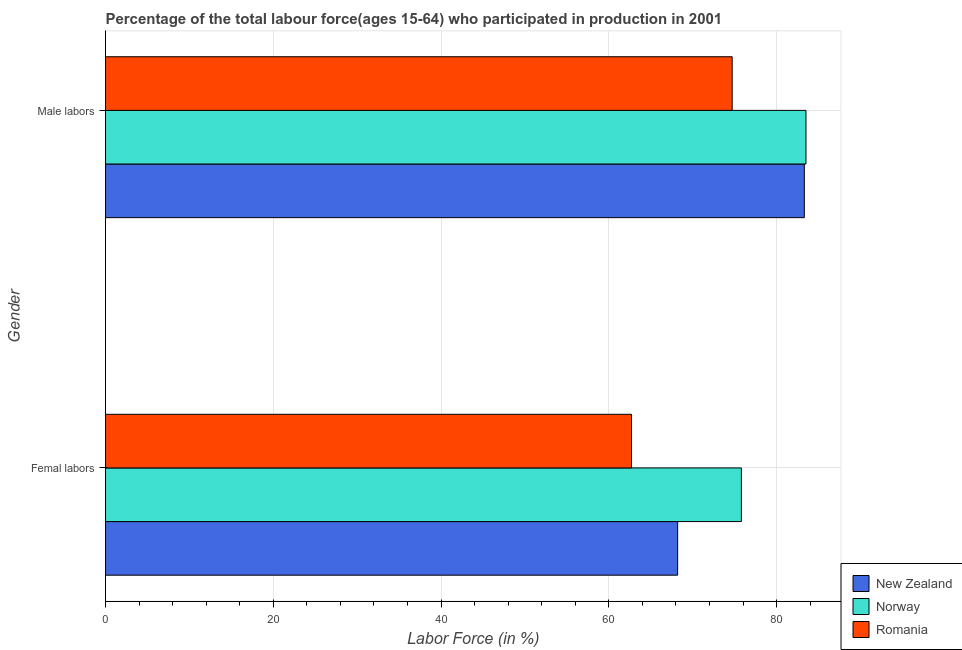How many groups of bars are there?
Keep it short and to the point. 2. Are the number of bars per tick equal to the number of legend labels?
Keep it short and to the point. Yes. How many bars are there on the 2nd tick from the top?
Offer a very short reply. 3. How many bars are there on the 1st tick from the bottom?
Offer a terse response. 3. What is the label of the 2nd group of bars from the top?
Provide a succinct answer. Femal labors. What is the percentage of female labor force in Norway?
Keep it short and to the point. 75.8. Across all countries, what is the maximum percentage of male labour force?
Offer a terse response. 83.5. Across all countries, what is the minimum percentage of male labour force?
Keep it short and to the point. 74.7. In which country was the percentage of male labour force maximum?
Give a very brief answer. Norway. In which country was the percentage of male labour force minimum?
Provide a succinct answer. Romania. What is the total percentage of female labor force in the graph?
Keep it short and to the point. 206.7. What is the difference between the percentage of female labor force in Romania and that in New Zealand?
Provide a short and direct response. -5.5. What is the difference between the percentage of female labor force in New Zealand and the percentage of male labour force in Romania?
Ensure brevity in your answer.  -6.5. What is the average percentage of female labor force per country?
Your answer should be compact. 68.9. What is the difference between the percentage of male labour force and percentage of female labor force in Romania?
Your answer should be compact. 12. In how many countries, is the percentage of female labor force greater than 52 %?
Give a very brief answer. 3. What is the ratio of the percentage of male labour force in Romania to that in Norway?
Provide a short and direct response. 0.89. Is the percentage of female labor force in Romania less than that in Norway?
Your answer should be compact. Yes. What does the 1st bar from the top in Femal labors represents?
Keep it short and to the point. Romania. How many bars are there?
Make the answer very short. 6. What is the difference between two consecutive major ticks on the X-axis?
Keep it short and to the point. 20. Are the values on the major ticks of X-axis written in scientific E-notation?
Keep it short and to the point. No. Does the graph contain grids?
Your response must be concise. Yes. What is the title of the graph?
Your answer should be compact. Percentage of the total labour force(ages 15-64) who participated in production in 2001. What is the label or title of the X-axis?
Make the answer very short. Labor Force (in %). What is the label or title of the Y-axis?
Give a very brief answer. Gender. What is the Labor Force (in %) in New Zealand in Femal labors?
Your answer should be compact. 68.2. What is the Labor Force (in %) of Norway in Femal labors?
Keep it short and to the point. 75.8. What is the Labor Force (in %) of Romania in Femal labors?
Keep it short and to the point. 62.7. What is the Labor Force (in %) in New Zealand in Male labors?
Provide a succinct answer. 83.3. What is the Labor Force (in %) of Norway in Male labors?
Make the answer very short. 83.5. What is the Labor Force (in %) of Romania in Male labors?
Ensure brevity in your answer.  74.7. Across all Gender, what is the maximum Labor Force (in %) in New Zealand?
Keep it short and to the point. 83.3. Across all Gender, what is the maximum Labor Force (in %) of Norway?
Make the answer very short. 83.5. Across all Gender, what is the maximum Labor Force (in %) in Romania?
Make the answer very short. 74.7. Across all Gender, what is the minimum Labor Force (in %) of New Zealand?
Ensure brevity in your answer.  68.2. Across all Gender, what is the minimum Labor Force (in %) of Norway?
Offer a very short reply. 75.8. Across all Gender, what is the minimum Labor Force (in %) in Romania?
Offer a very short reply. 62.7. What is the total Labor Force (in %) in New Zealand in the graph?
Ensure brevity in your answer.  151.5. What is the total Labor Force (in %) in Norway in the graph?
Keep it short and to the point. 159.3. What is the total Labor Force (in %) in Romania in the graph?
Provide a short and direct response. 137.4. What is the difference between the Labor Force (in %) in New Zealand in Femal labors and that in Male labors?
Your answer should be very brief. -15.1. What is the difference between the Labor Force (in %) in Romania in Femal labors and that in Male labors?
Provide a short and direct response. -12. What is the difference between the Labor Force (in %) of New Zealand in Femal labors and the Labor Force (in %) of Norway in Male labors?
Your response must be concise. -15.3. What is the difference between the Labor Force (in %) in New Zealand in Femal labors and the Labor Force (in %) in Romania in Male labors?
Give a very brief answer. -6.5. What is the average Labor Force (in %) in New Zealand per Gender?
Your response must be concise. 75.75. What is the average Labor Force (in %) in Norway per Gender?
Your answer should be very brief. 79.65. What is the average Labor Force (in %) in Romania per Gender?
Ensure brevity in your answer.  68.7. What is the difference between the Labor Force (in %) of New Zealand and Labor Force (in %) of Norway in Femal labors?
Your answer should be very brief. -7.6. What is the difference between the Labor Force (in %) of New Zealand and Labor Force (in %) of Romania in Femal labors?
Your answer should be very brief. 5.5. What is the difference between the Labor Force (in %) of Norway and Labor Force (in %) of Romania in Femal labors?
Your answer should be compact. 13.1. What is the difference between the Labor Force (in %) of New Zealand and Labor Force (in %) of Norway in Male labors?
Offer a very short reply. -0.2. What is the difference between the Labor Force (in %) of New Zealand and Labor Force (in %) of Romania in Male labors?
Provide a succinct answer. 8.6. What is the difference between the Labor Force (in %) of Norway and Labor Force (in %) of Romania in Male labors?
Your answer should be compact. 8.8. What is the ratio of the Labor Force (in %) of New Zealand in Femal labors to that in Male labors?
Your response must be concise. 0.82. What is the ratio of the Labor Force (in %) of Norway in Femal labors to that in Male labors?
Provide a succinct answer. 0.91. What is the ratio of the Labor Force (in %) in Romania in Femal labors to that in Male labors?
Offer a very short reply. 0.84. What is the difference between the highest and the second highest Labor Force (in %) of New Zealand?
Your answer should be very brief. 15.1. What is the difference between the highest and the second highest Labor Force (in %) in Norway?
Your answer should be very brief. 7.7. What is the difference between the highest and the lowest Labor Force (in %) of New Zealand?
Your answer should be very brief. 15.1. 